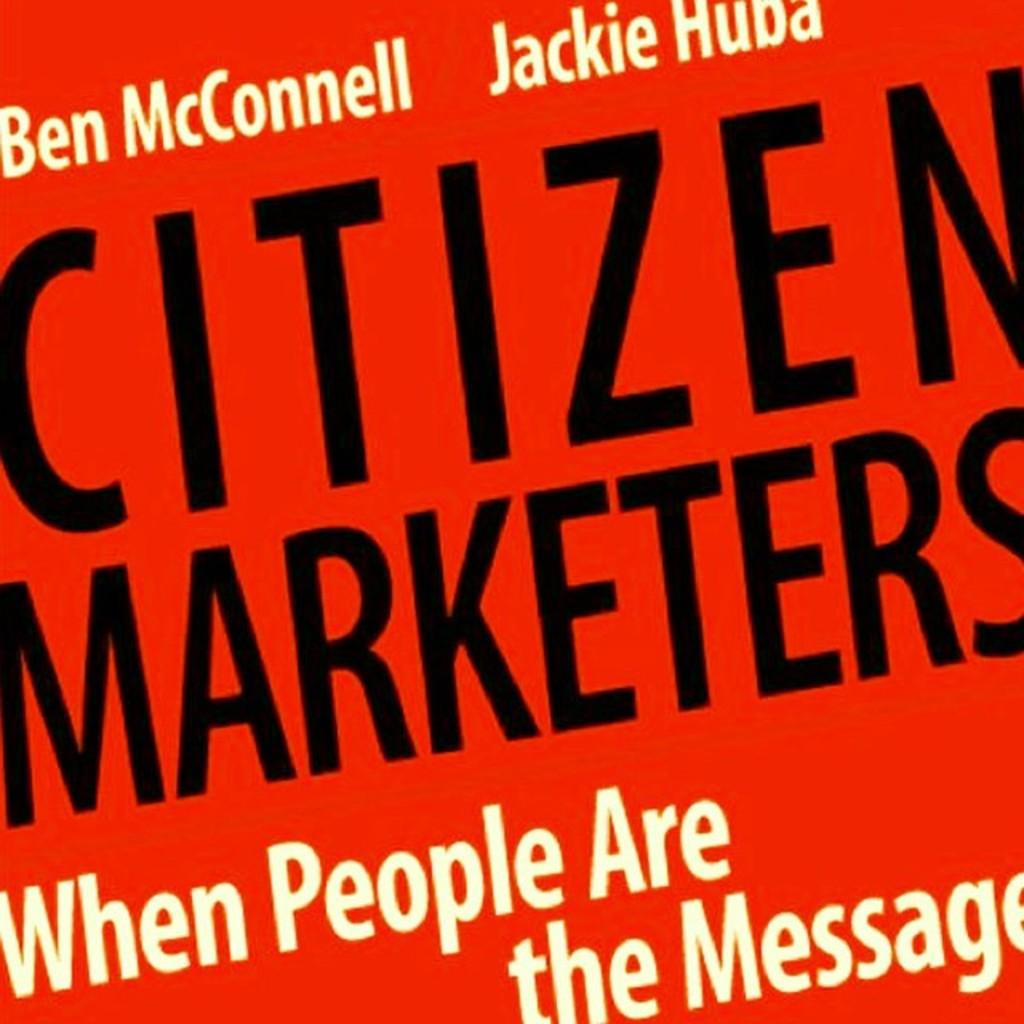<image>
Summarize the visual content of the image. Red background with black letters that say "Citizen Marketers". 